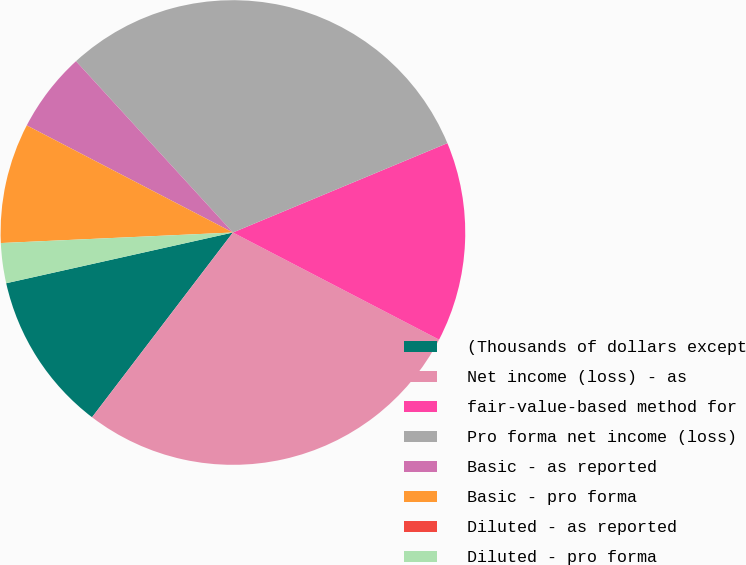<chart> <loc_0><loc_0><loc_500><loc_500><pie_chart><fcel>(Thousands of dollars except<fcel>Net income (loss) - as<fcel>fair-value-based method for<fcel>Pro forma net income (loss)<fcel>Basic - as reported<fcel>Basic - pro forma<fcel>Diluted - as reported<fcel>Diluted - pro forma<nl><fcel>11.13%<fcel>27.74%<fcel>13.91%<fcel>30.52%<fcel>5.57%<fcel>8.35%<fcel>0.0%<fcel>2.78%<nl></chart> 